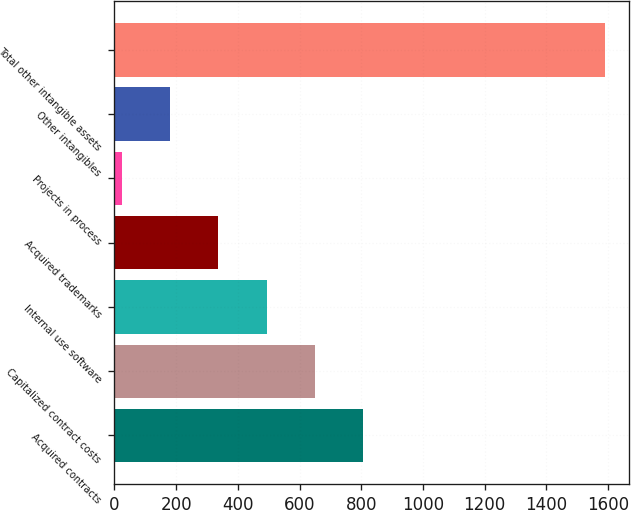Convert chart. <chart><loc_0><loc_0><loc_500><loc_500><bar_chart><fcel>Acquired contracts<fcel>Capitalized contract costs<fcel>Internal use software<fcel>Acquired trademarks<fcel>Projects in process<fcel>Other intangibles<fcel>Total other intangible assets<nl><fcel>806.45<fcel>649.86<fcel>493.27<fcel>336.68<fcel>23.5<fcel>180.09<fcel>1589.4<nl></chart> 